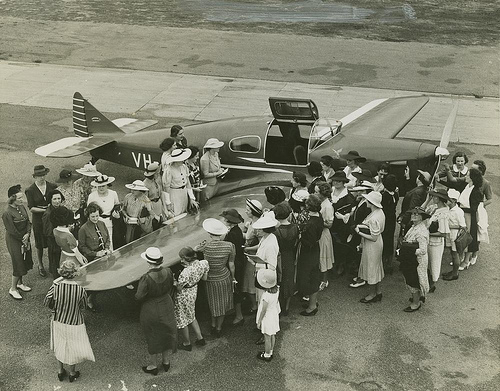How many airplanes are there? There is a single airplane in the image, which can be identified by its distinct wings and tail, surrounded by a group of interested onlookers. 